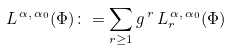Convert formula to latex. <formula><loc_0><loc_0><loc_500><loc_500>L ^ { \, \alpha , \, \alpha _ { 0 } } ( \Phi ) \colon = \sum _ { r \geq 1 } g ^ { \, r } \, L _ { r } ^ { \, \alpha , \, \alpha _ { 0 } } ( \Phi )</formula> 